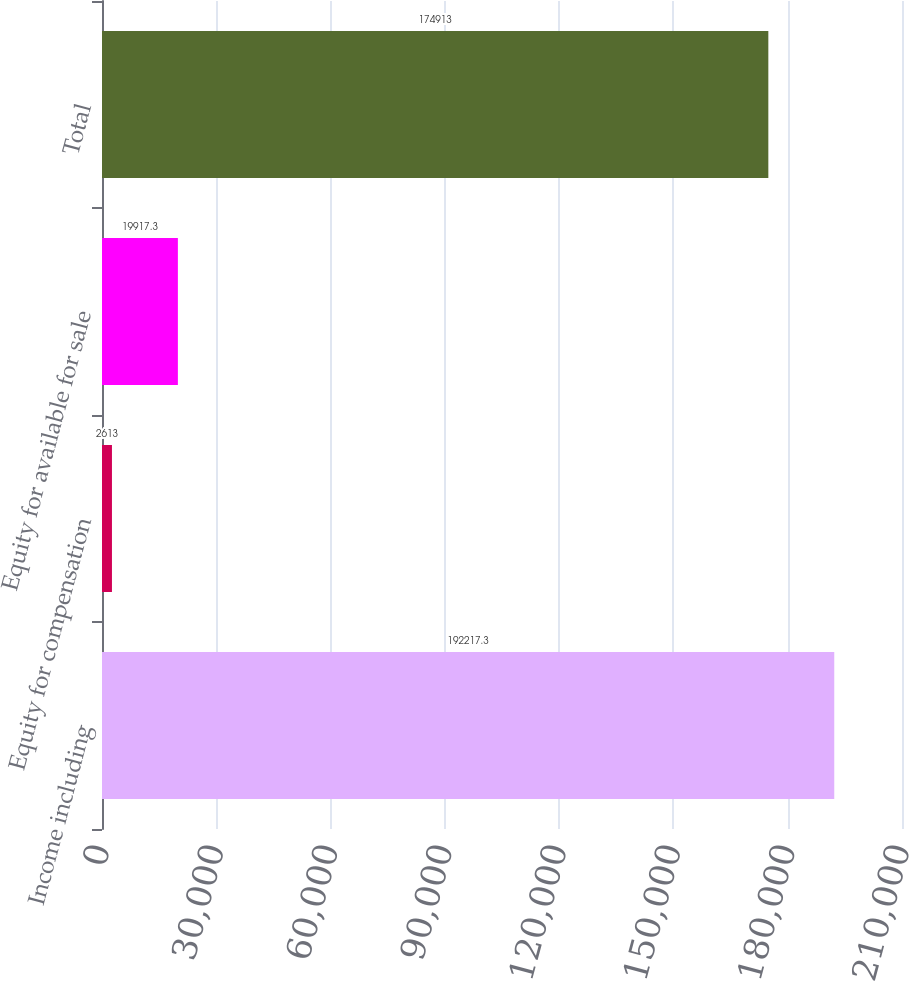Convert chart. <chart><loc_0><loc_0><loc_500><loc_500><bar_chart><fcel>Income including<fcel>Equity for compensation<fcel>Equity for available for sale<fcel>Total<nl><fcel>192217<fcel>2613<fcel>19917.3<fcel>174913<nl></chart> 